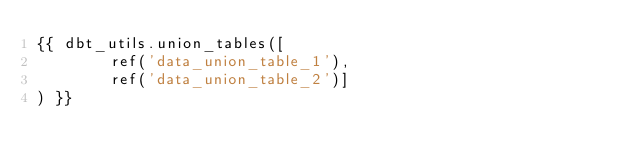<code> <loc_0><loc_0><loc_500><loc_500><_SQL_>{{ dbt_utils.union_tables([
        ref('data_union_table_1'),
        ref('data_union_table_2')]
) }} 

</code> 